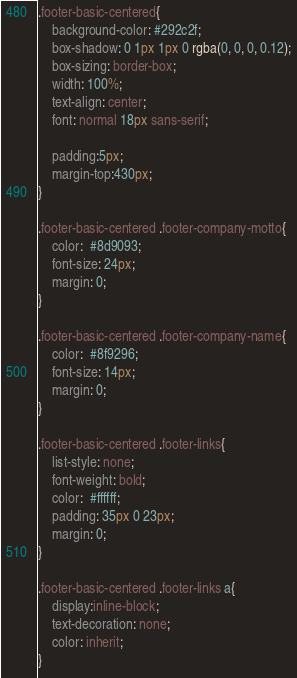<code> <loc_0><loc_0><loc_500><loc_500><_CSS_>
.footer-basic-centered{
	background-color: #292c2f;
	box-shadow: 0 1px 1px 0 rgba(0, 0, 0, 0.12);
	box-sizing: border-box;
	width: 100%;
	text-align: center;
	font: normal 18px sans-serif;

	padding:5px;
	margin-top:430px;
}

.footer-basic-centered .footer-company-motto{
	color:  #8d9093;
	font-size: 24px;
	margin: 0;
}

.footer-basic-centered .footer-company-name{
	color:  #8f9296;
	font-size: 14px;
	margin: 0;
}

.footer-basic-centered .footer-links{
	list-style: none;
	font-weight: bold;
	color:  #ffffff;
	padding: 35px 0 23px;
	margin: 0;
}

.footer-basic-centered .footer-links a{
	display:inline-block;
	text-decoration: none;
	color: inherit;
}


</code> 